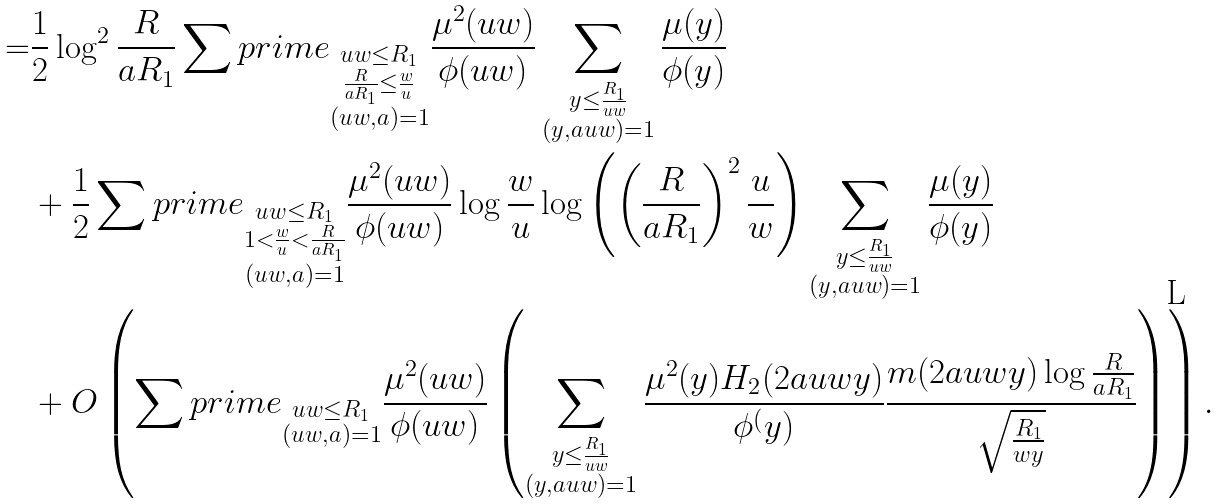<formula> <loc_0><loc_0><loc_500><loc_500>= & \frac { 1 } { 2 } \log ^ { 2 } \frac { R } { a R _ { 1 } } \sum p r i m e _ { \substack { u w \leq R _ { 1 } \\ \frac { R } { a R _ { 1 } } \leq \frac { w } { u } \\ ( u w , a ) = 1 } } \frac { \mu ^ { 2 } ( u w ) } { \phi ( u w ) } \sum _ { \substack { y \leq \frac { R _ { 1 } } { u w } \\ ( y , a u w ) = 1 } } \frac { \mu ( y ) } { \phi ( y ) } \\ & + \frac { 1 } { 2 } \sum p r i m e _ { \substack { u w \leq R _ { 1 } \\ 1 < \frac { w } { u } < \frac { R } { a R _ { 1 } } \\ ( u w , a ) = 1 } } \frac { \mu ^ { 2 } ( u w ) } { \phi ( u w ) } \log \frac { w } { u } \log \left ( \left ( \frac { R } { a R _ { 1 } } \right ) ^ { 2 } \frac { u } { w } \right ) \sum _ { \substack { y \leq \frac { R _ { 1 } } { u w } \\ ( y , a u w ) = 1 } } \frac { \mu ( y ) } { \phi ( y ) } \\ & + O \left ( \sum p r i m e _ { \substack { u w \leq R _ { 1 } \\ ( u w , a ) = 1 } } \frac { \mu ^ { 2 } ( u w ) } { \phi ( u w ) } \left ( \sum _ { \substack { y \leq \frac { R _ { 1 } } { u w } \\ ( y , a u w ) = 1 } } \frac { \mu ^ { 2 } ( y ) H _ { 2 } ( 2 a u w y ) } { \phi ^ { ( } y ) } \frac { m ( 2 a u w y ) \log \frac { R } { a R _ { 1 } } } { \sqrt { \frac { R _ { 1 } } { w y } } } \right ) \right ) .</formula> 